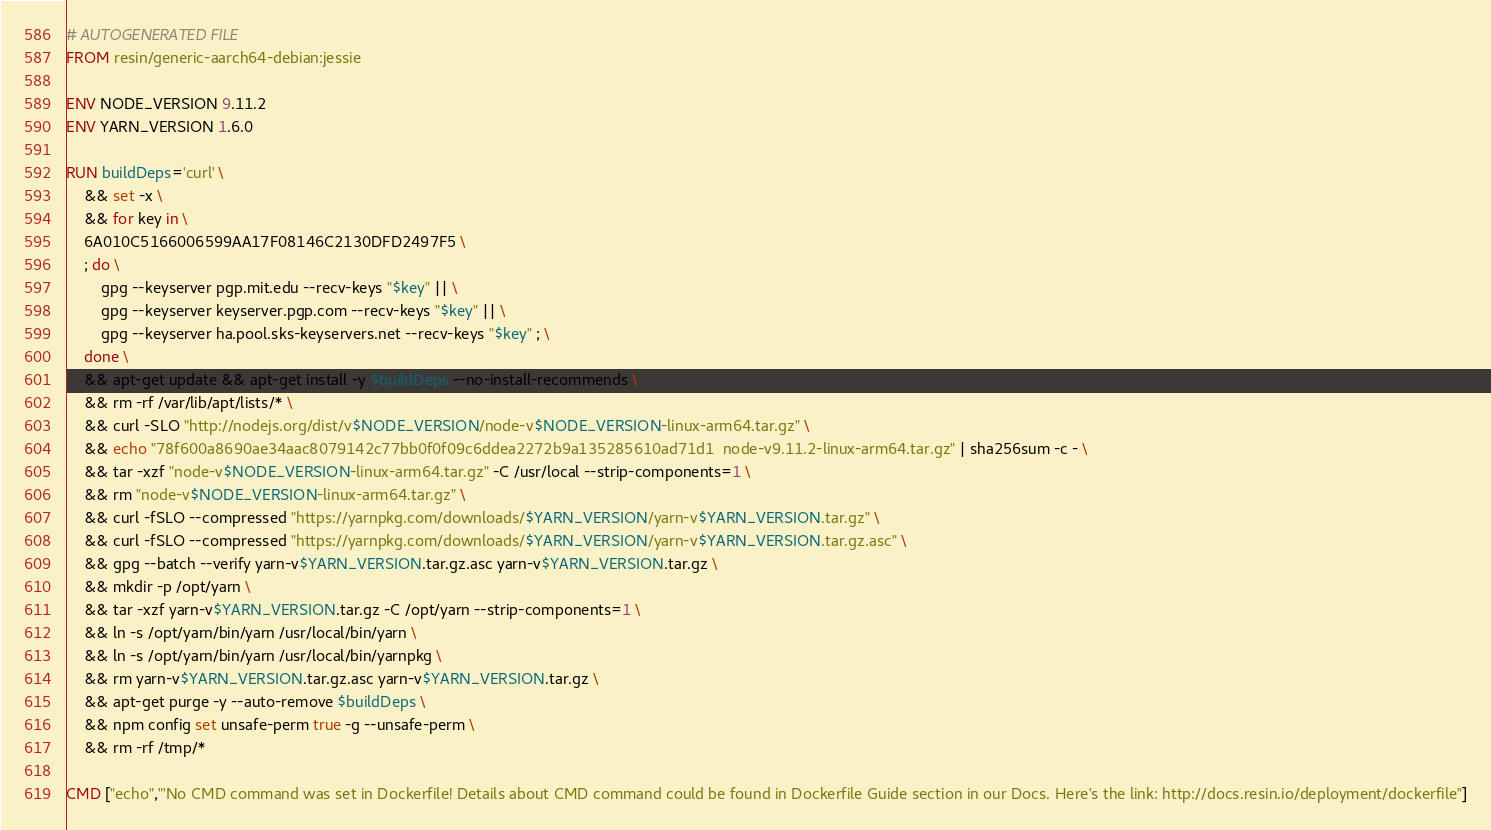<code> <loc_0><loc_0><loc_500><loc_500><_Dockerfile_># AUTOGENERATED FILE
FROM resin/generic-aarch64-debian:jessie

ENV NODE_VERSION 9.11.2
ENV YARN_VERSION 1.6.0

RUN buildDeps='curl' \
	&& set -x \
	&& for key in \
	6A010C5166006599AA17F08146C2130DFD2497F5 \
	; do \
		gpg --keyserver pgp.mit.edu --recv-keys "$key" || \
		gpg --keyserver keyserver.pgp.com --recv-keys "$key" || \
		gpg --keyserver ha.pool.sks-keyservers.net --recv-keys "$key" ; \
	done \
	&& apt-get update && apt-get install -y $buildDeps --no-install-recommends \
	&& rm -rf /var/lib/apt/lists/* \
	&& curl -SLO "http://nodejs.org/dist/v$NODE_VERSION/node-v$NODE_VERSION-linux-arm64.tar.gz" \
	&& echo "78f600a8690ae34aac8079142c77bb0f0f09c6ddea2272b9a135285610ad71d1  node-v9.11.2-linux-arm64.tar.gz" | sha256sum -c - \
	&& tar -xzf "node-v$NODE_VERSION-linux-arm64.tar.gz" -C /usr/local --strip-components=1 \
	&& rm "node-v$NODE_VERSION-linux-arm64.tar.gz" \
	&& curl -fSLO --compressed "https://yarnpkg.com/downloads/$YARN_VERSION/yarn-v$YARN_VERSION.tar.gz" \
	&& curl -fSLO --compressed "https://yarnpkg.com/downloads/$YARN_VERSION/yarn-v$YARN_VERSION.tar.gz.asc" \
	&& gpg --batch --verify yarn-v$YARN_VERSION.tar.gz.asc yarn-v$YARN_VERSION.tar.gz \
	&& mkdir -p /opt/yarn \
	&& tar -xzf yarn-v$YARN_VERSION.tar.gz -C /opt/yarn --strip-components=1 \
	&& ln -s /opt/yarn/bin/yarn /usr/local/bin/yarn \
	&& ln -s /opt/yarn/bin/yarn /usr/local/bin/yarnpkg \
	&& rm yarn-v$YARN_VERSION.tar.gz.asc yarn-v$YARN_VERSION.tar.gz \
	&& apt-get purge -y --auto-remove $buildDeps \
	&& npm config set unsafe-perm true -g --unsafe-perm \
	&& rm -rf /tmp/*

CMD ["echo","'No CMD command was set in Dockerfile! Details about CMD command could be found in Dockerfile Guide section in our Docs. Here's the link: http://docs.resin.io/deployment/dockerfile"]
</code> 